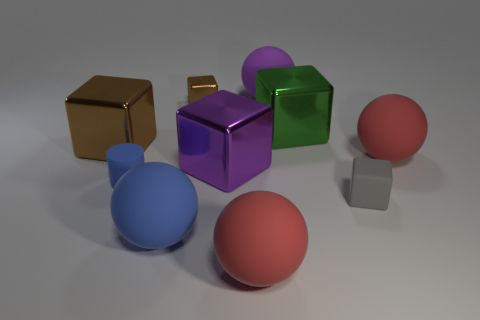Subtract all purple cubes. How many cubes are left? 4 Subtract all large purple cubes. How many cubes are left? 4 Subtract all yellow cubes. Subtract all yellow balls. How many cubes are left? 5 Subtract all cylinders. How many objects are left? 9 Subtract all tiny blue rubber things. Subtract all tiny yellow objects. How many objects are left? 9 Add 2 red matte balls. How many red matte balls are left? 4 Add 1 purple rubber things. How many purple rubber things exist? 2 Subtract 1 purple cubes. How many objects are left? 9 